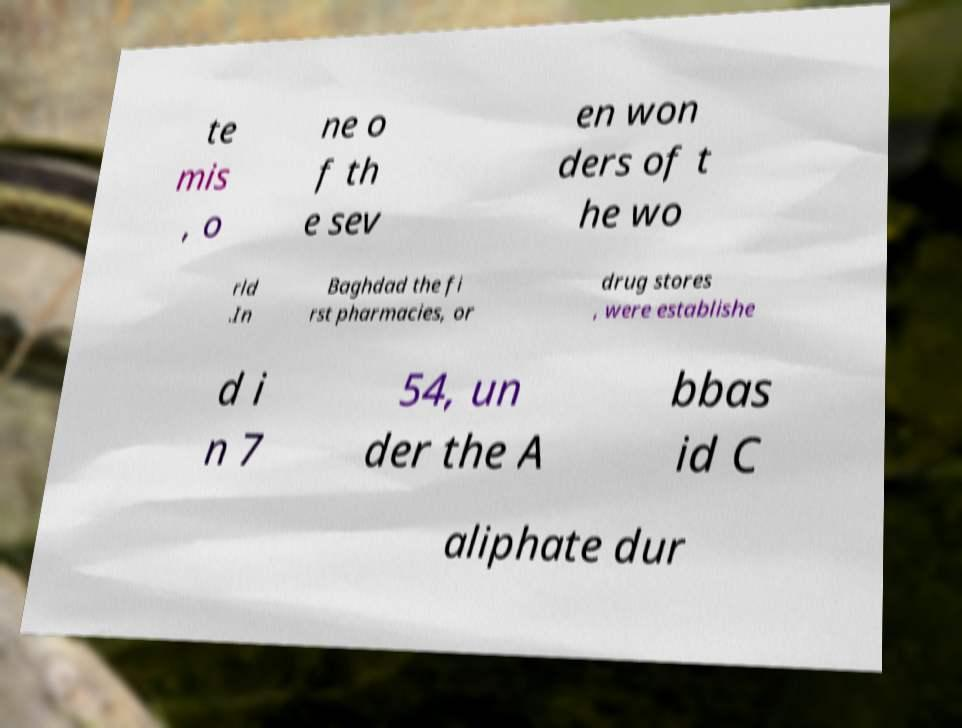I need the written content from this picture converted into text. Can you do that? te mis , o ne o f th e sev en won ders of t he wo rld .In Baghdad the fi rst pharmacies, or drug stores , were establishe d i n 7 54, un der the A bbas id C aliphate dur 